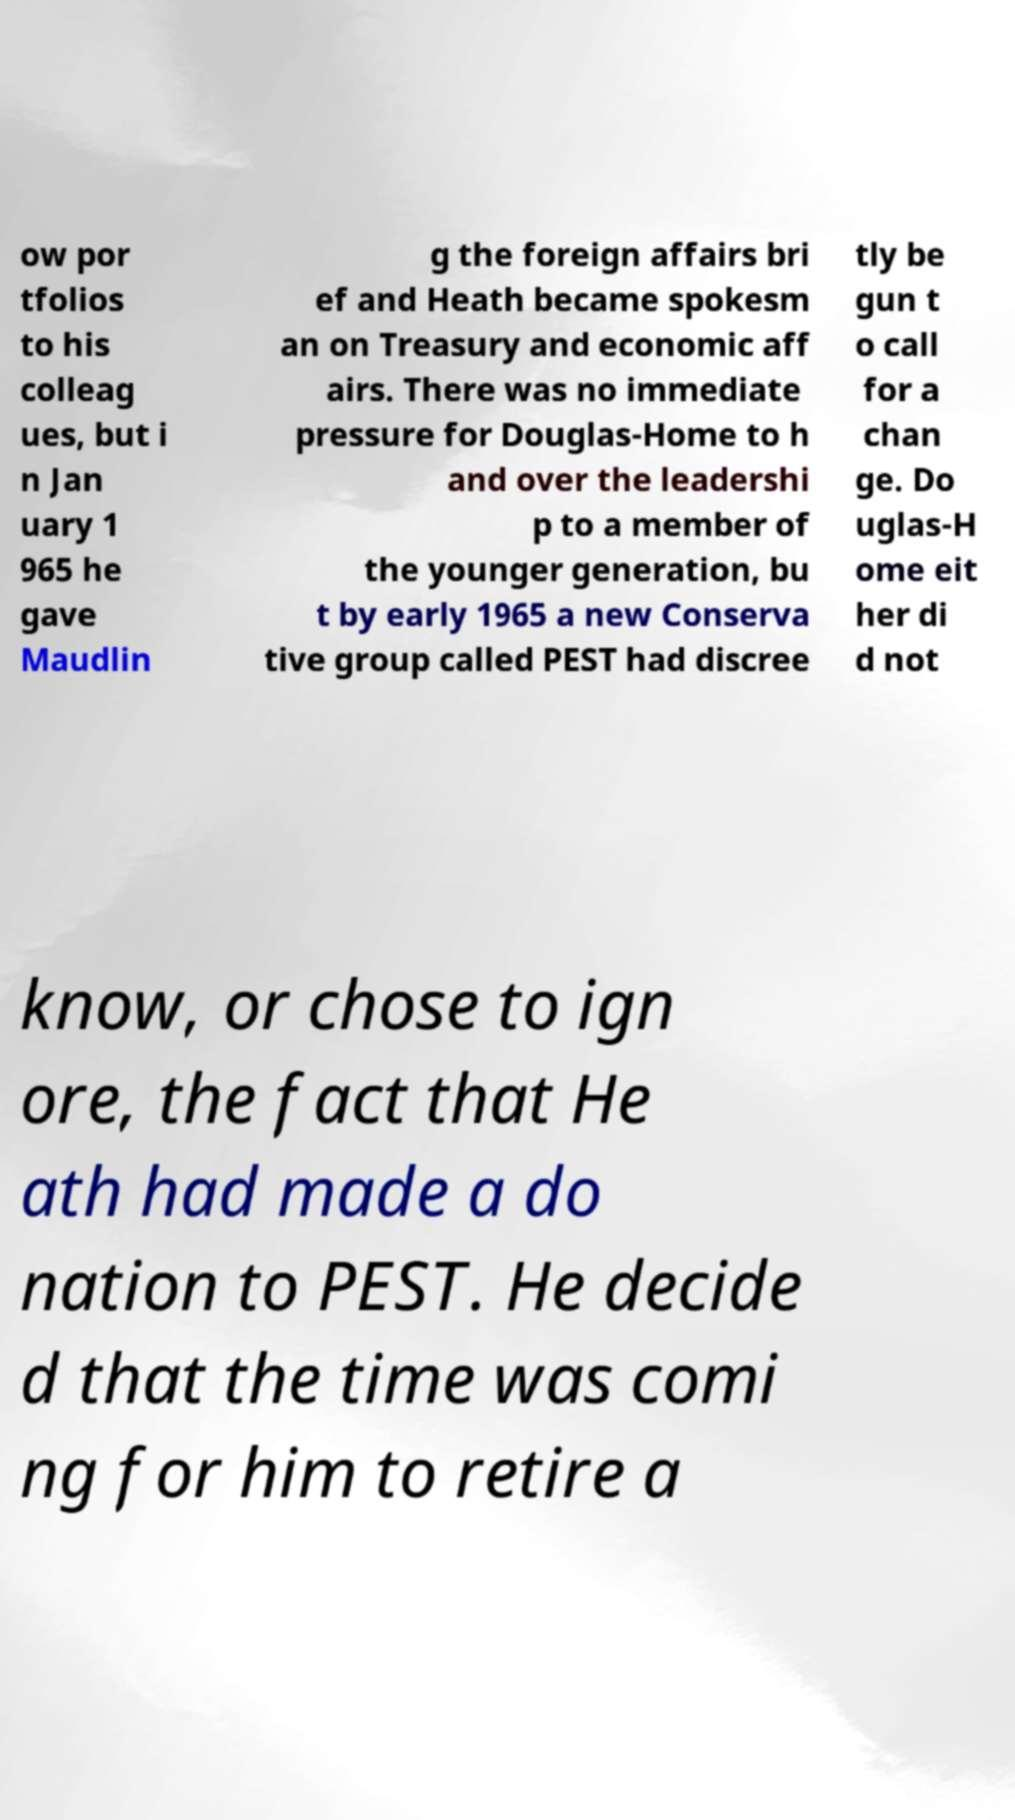What messages or text are displayed in this image? I need them in a readable, typed format. ow por tfolios to his colleag ues, but i n Jan uary 1 965 he gave Maudlin g the foreign affairs bri ef and Heath became spokesm an on Treasury and economic aff airs. There was no immediate pressure for Douglas-Home to h and over the leadershi p to a member of the younger generation, bu t by early 1965 a new Conserva tive group called PEST had discree tly be gun t o call for a chan ge. Do uglas-H ome eit her di d not know, or chose to ign ore, the fact that He ath had made a do nation to PEST. He decide d that the time was comi ng for him to retire a 